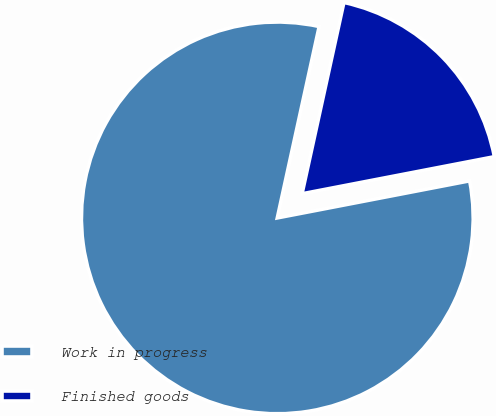<chart> <loc_0><loc_0><loc_500><loc_500><pie_chart><fcel>Work in progress<fcel>Finished goods<nl><fcel>81.46%<fcel>18.54%<nl></chart> 